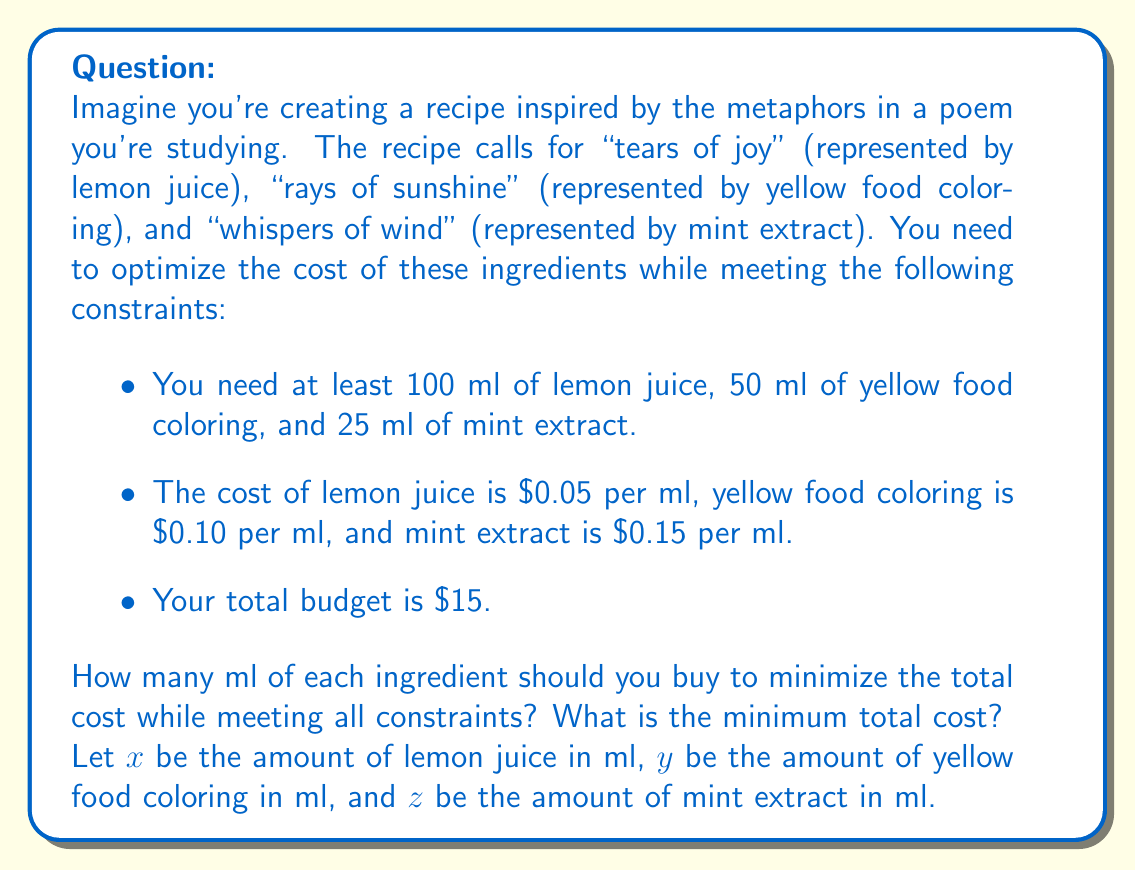Can you solve this math problem? To solve this optimization problem, we'll use linear programming. First, let's set up the problem:

Objective function (to minimize):
$$ f(x,y,z) = 0.05x + 0.10y + 0.15z $$

Constraints:
1. $x \geq 100$ (lemon juice)
2. $y \geq 50$ (yellow food coloring)
3. $z \geq 25$ (mint extract)
4. $0.05x + 0.10y + 0.15z \leq 15$ (budget constraint)

We want to minimize the objective function subject to these constraints. Since the cost per ml is fixed for each ingredient, the optimal solution will be to use the minimum required amount of each ingredient:

$x = 100$ ml of lemon juice
$y = 50$ ml of yellow food coloring
$z = 25$ ml of mint extract

Let's verify that this solution satisfies the budget constraint:

$$ 0.05(100) + 0.10(50) + 0.15(25) = 5 + 5 + 3.75 = 13.75 \leq 15 $$

The total cost is $13.75, which is within the budget of $15.

This solution is optimal because:
1. It satisfies all constraints.
2. Using less of any ingredient would violate the minimum required amounts.
3. Using more of any ingredient would increase the total cost unnecessarily.
Answer: Optimal solution:
- Lemon juice (tears of joy): 100 ml
- Yellow food coloring (rays of sunshine): 50 ml
- Mint extract (whispers of wind): 25 ml

Minimum total cost: $13.75 